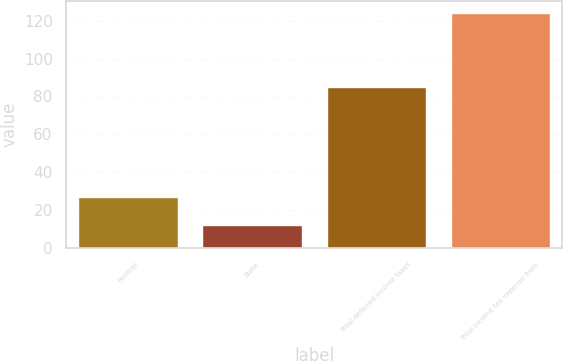Convert chart to OTSL. <chart><loc_0><loc_0><loc_500><loc_500><bar_chart><fcel>Federal<fcel>State<fcel>Total deferred income taxes<fcel>Total income tax expense from<nl><fcel>27<fcel>12<fcel>85<fcel>124<nl></chart> 